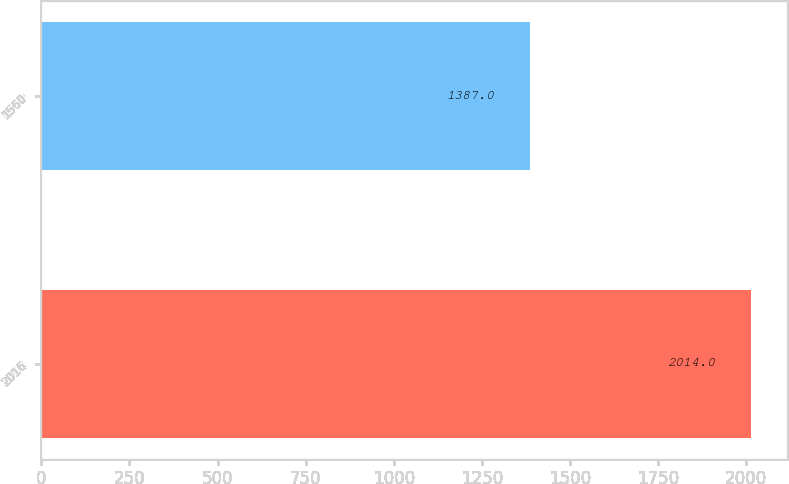Convert chart to OTSL. <chart><loc_0><loc_0><loc_500><loc_500><bar_chart><fcel>2016<fcel>1560<nl><fcel>2014<fcel>1387<nl></chart> 